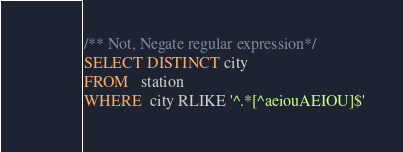Convert code to text. <code><loc_0><loc_0><loc_500><loc_500><_SQL_>/** Not, Negate regular expression*/
SELECT DISTINCT city
FROM   station
WHERE  city RLIKE '^.*[^aeiouAEIOU]$'</code> 